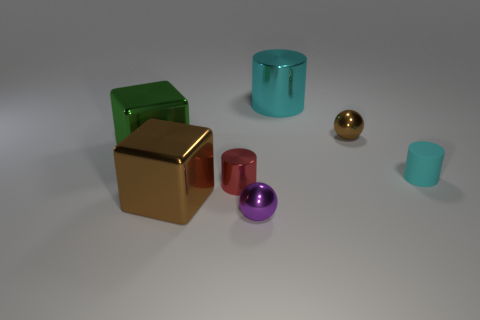Are there any other things that are the same material as the small cyan thing?
Make the answer very short. No. There is a small cylinder that is behind the small shiny cylinder; what is it made of?
Provide a succinct answer. Rubber. Do the big brown metal object and the green object have the same shape?
Ensure brevity in your answer.  Yes. What color is the metallic sphere that is to the right of the cyan cylinder that is behind the cyan cylinder that is on the right side of the tiny brown object?
Offer a terse response. Brown. What number of large cyan things are the same shape as the big green metal thing?
Keep it short and to the point. 0. What is the size of the brown thing to the right of the brown metal object that is in front of the brown sphere?
Give a very brief answer. Small. Is the size of the brown metallic sphere the same as the cyan metallic object?
Provide a succinct answer. No. Are there any small purple spheres that are in front of the green block that is to the left of the brown object in front of the brown shiny sphere?
Give a very brief answer. Yes. What size is the red object?
Give a very brief answer. Small. How many brown metallic things have the same size as the matte cylinder?
Give a very brief answer. 1. 